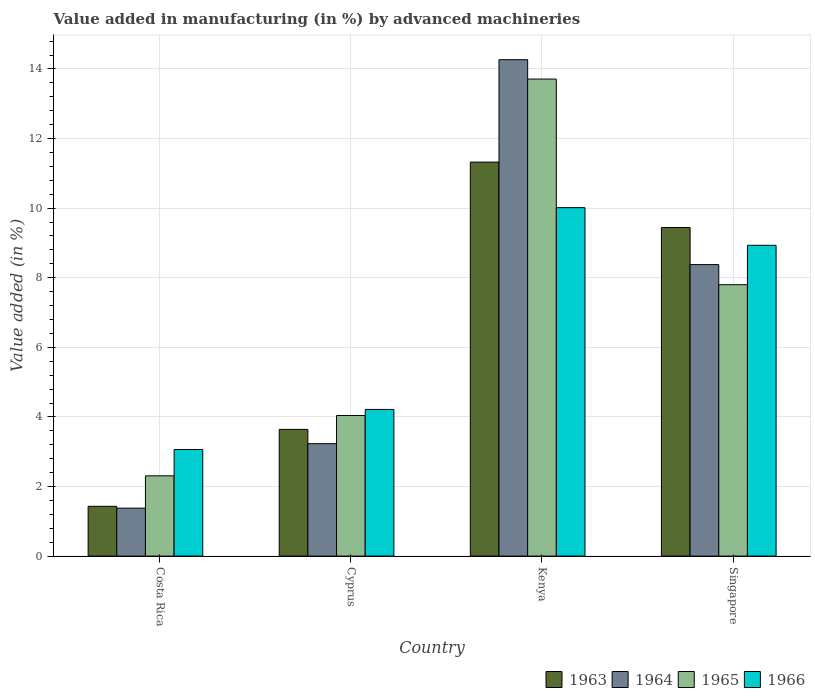How many different coloured bars are there?
Your answer should be compact. 4. How many bars are there on the 4th tick from the right?
Offer a very short reply. 4. What is the label of the 4th group of bars from the left?
Your answer should be very brief. Singapore. What is the percentage of value added in manufacturing by advanced machineries in 1964 in Singapore?
Give a very brief answer. 8.38. Across all countries, what is the maximum percentage of value added in manufacturing by advanced machineries in 1964?
Your response must be concise. 14.27. Across all countries, what is the minimum percentage of value added in manufacturing by advanced machineries in 1966?
Your answer should be compact. 3.06. In which country was the percentage of value added in manufacturing by advanced machineries in 1963 maximum?
Provide a succinct answer. Kenya. What is the total percentage of value added in manufacturing by advanced machineries in 1965 in the graph?
Keep it short and to the point. 27.86. What is the difference between the percentage of value added in manufacturing by advanced machineries in 1966 in Costa Rica and that in Kenya?
Your answer should be very brief. -6.95. What is the difference between the percentage of value added in manufacturing by advanced machineries in 1963 in Cyprus and the percentage of value added in manufacturing by advanced machineries in 1965 in Kenya?
Your response must be concise. -10.07. What is the average percentage of value added in manufacturing by advanced machineries in 1965 per country?
Provide a succinct answer. 6.96. What is the difference between the percentage of value added in manufacturing by advanced machineries of/in 1966 and percentage of value added in manufacturing by advanced machineries of/in 1963 in Kenya?
Your response must be concise. -1.31. What is the ratio of the percentage of value added in manufacturing by advanced machineries in 1965 in Costa Rica to that in Cyprus?
Offer a terse response. 0.57. What is the difference between the highest and the second highest percentage of value added in manufacturing by advanced machineries in 1965?
Offer a very short reply. -9.67. What is the difference between the highest and the lowest percentage of value added in manufacturing by advanced machineries in 1966?
Ensure brevity in your answer.  6.95. In how many countries, is the percentage of value added in manufacturing by advanced machineries in 1966 greater than the average percentage of value added in manufacturing by advanced machineries in 1966 taken over all countries?
Your answer should be very brief. 2. Is the sum of the percentage of value added in manufacturing by advanced machineries in 1963 in Kenya and Singapore greater than the maximum percentage of value added in manufacturing by advanced machineries in 1965 across all countries?
Your answer should be very brief. Yes. Is it the case that in every country, the sum of the percentage of value added in manufacturing by advanced machineries in 1964 and percentage of value added in manufacturing by advanced machineries in 1963 is greater than the sum of percentage of value added in manufacturing by advanced machineries in 1966 and percentage of value added in manufacturing by advanced machineries in 1965?
Provide a short and direct response. No. What does the 3rd bar from the left in Costa Rica represents?
Make the answer very short. 1965. What does the 4th bar from the right in Kenya represents?
Keep it short and to the point. 1963. How many bars are there?
Your answer should be very brief. 16. What is the difference between two consecutive major ticks on the Y-axis?
Ensure brevity in your answer.  2. Are the values on the major ticks of Y-axis written in scientific E-notation?
Your answer should be compact. No. How many legend labels are there?
Offer a terse response. 4. How are the legend labels stacked?
Keep it short and to the point. Horizontal. What is the title of the graph?
Make the answer very short. Value added in manufacturing (in %) by advanced machineries. Does "1978" appear as one of the legend labels in the graph?
Offer a very short reply. No. What is the label or title of the X-axis?
Provide a short and direct response. Country. What is the label or title of the Y-axis?
Your answer should be very brief. Value added (in %). What is the Value added (in %) in 1963 in Costa Rica?
Your answer should be compact. 1.43. What is the Value added (in %) in 1964 in Costa Rica?
Your answer should be compact. 1.38. What is the Value added (in %) in 1965 in Costa Rica?
Give a very brief answer. 2.31. What is the Value added (in %) of 1966 in Costa Rica?
Keep it short and to the point. 3.06. What is the Value added (in %) in 1963 in Cyprus?
Your answer should be very brief. 3.64. What is the Value added (in %) in 1964 in Cyprus?
Make the answer very short. 3.23. What is the Value added (in %) in 1965 in Cyprus?
Keep it short and to the point. 4.04. What is the Value added (in %) of 1966 in Cyprus?
Your response must be concise. 4.22. What is the Value added (in %) in 1963 in Kenya?
Keep it short and to the point. 11.32. What is the Value added (in %) of 1964 in Kenya?
Your answer should be compact. 14.27. What is the Value added (in %) in 1965 in Kenya?
Your answer should be very brief. 13.71. What is the Value added (in %) of 1966 in Kenya?
Make the answer very short. 10.01. What is the Value added (in %) in 1963 in Singapore?
Offer a very short reply. 9.44. What is the Value added (in %) in 1964 in Singapore?
Ensure brevity in your answer.  8.38. What is the Value added (in %) in 1965 in Singapore?
Provide a succinct answer. 7.8. What is the Value added (in %) in 1966 in Singapore?
Ensure brevity in your answer.  8.93. Across all countries, what is the maximum Value added (in %) of 1963?
Ensure brevity in your answer.  11.32. Across all countries, what is the maximum Value added (in %) in 1964?
Your answer should be very brief. 14.27. Across all countries, what is the maximum Value added (in %) of 1965?
Keep it short and to the point. 13.71. Across all countries, what is the maximum Value added (in %) in 1966?
Ensure brevity in your answer.  10.01. Across all countries, what is the minimum Value added (in %) in 1963?
Your answer should be compact. 1.43. Across all countries, what is the minimum Value added (in %) of 1964?
Provide a short and direct response. 1.38. Across all countries, what is the minimum Value added (in %) of 1965?
Keep it short and to the point. 2.31. Across all countries, what is the minimum Value added (in %) of 1966?
Ensure brevity in your answer.  3.06. What is the total Value added (in %) in 1963 in the graph?
Your answer should be very brief. 25.84. What is the total Value added (in %) of 1964 in the graph?
Provide a short and direct response. 27.25. What is the total Value added (in %) in 1965 in the graph?
Your answer should be very brief. 27.86. What is the total Value added (in %) of 1966 in the graph?
Provide a succinct answer. 26.23. What is the difference between the Value added (in %) in 1963 in Costa Rica and that in Cyprus?
Keep it short and to the point. -2.21. What is the difference between the Value added (in %) in 1964 in Costa Rica and that in Cyprus?
Provide a succinct answer. -1.85. What is the difference between the Value added (in %) of 1965 in Costa Rica and that in Cyprus?
Your answer should be compact. -1.73. What is the difference between the Value added (in %) of 1966 in Costa Rica and that in Cyprus?
Provide a short and direct response. -1.15. What is the difference between the Value added (in %) in 1963 in Costa Rica and that in Kenya?
Give a very brief answer. -9.89. What is the difference between the Value added (in %) of 1964 in Costa Rica and that in Kenya?
Ensure brevity in your answer.  -12.89. What is the difference between the Value added (in %) of 1965 in Costa Rica and that in Kenya?
Keep it short and to the point. -11.4. What is the difference between the Value added (in %) of 1966 in Costa Rica and that in Kenya?
Provide a succinct answer. -6.95. What is the difference between the Value added (in %) in 1963 in Costa Rica and that in Singapore?
Your answer should be very brief. -8.01. What is the difference between the Value added (in %) in 1964 in Costa Rica and that in Singapore?
Your response must be concise. -7. What is the difference between the Value added (in %) of 1965 in Costa Rica and that in Singapore?
Your answer should be compact. -5.49. What is the difference between the Value added (in %) of 1966 in Costa Rica and that in Singapore?
Your response must be concise. -5.87. What is the difference between the Value added (in %) of 1963 in Cyprus and that in Kenya?
Provide a succinct answer. -7.68. What is the difference between the Value added (in %) in 1964 in Cyprus and that in Kenya?
Keep it short and to the point. -11.04. What is the difference between the Value added (in %) of 1965 in Cyprus and that in Kenya?
Your answer should be very brief. -9.67. What is the difference between the Value added (in %) of 1966 in Cyprus and that in Kenya?
Keep it short and to the point. -5.8. What is the difference between the Value added (in %) in 1963 in Cyprus and that in Singapore?
Your response must be concise. -5.8. What is the difference between the Value added (in %) in 1964 in Cyprus and that in Singapore?
Keep it short and to the point. -5.15. What is the difference between the Value added (in %) of 1965 in Cyprus and that in Singapore?
Your answer should be compact. -3.76. What is the difference between the Value added (in %) in 1966 in Cyprus and that in Singapore?
Make the answer very short. -4.72. What is the difference between the Value added (in %) of 1963 in Kenya and that in Singapore?
Your answer should be compact. 1.88. What is the difference between the Value added (in %) in 1964 in Kenya and that in Singapore?
Keep it short and to the point. 5.89. What is the difference between the Value added (in %) of 1965 in Kenya and that in Singapore?
Your answer should be compact. 5.91. What is the difference between the Value added (in %) in 1966 in Kenya and that in Singapore?
Your answer should be very brief. 1.08. What is the difference between the Value added (in %) in 1963 in Costa Rica and the Value added (in %) in 1964 in Cyprus?
Keep it short and to the point. -1.8. What is the difference between the Value added (in %) of 1963 in Costa Rica and the Value added (in %) of 1965 in Cyprus?
Keep it short and to the point. -2.61. What is the difference between the Value added (in %) in 1963 in Costa Rica and the Value added (in %) in 1966 in Cyprus?
Provide a succinct answer. -2.78. What is the difference between the Value added (in %) of 1964 in Costa Rica and the Value added (in %) of 1965 in Cyprus?
Provide a succinct answer. -2.66. What is the difference between the Value added (in %) in 1964 in Costa Rica and the Value added (in %) in 1966 in Cyprus?
Keep it short and to the point. -2.84. What is the difference between the Value added (in %) of 1965 in Costa Rica and the Value added (in %) of 1966 in Cyprus?
Your response must be concise. -1.91. What is the difference between the Value added (in %) of 1963 in Costa Rica and the Value added (in %) of 1964 in Kenya?
Offer a terse response. -12.84. What is the difference between the Value added (in %) in 1963 in Costa Rica and the Value added (in %) in 1965 in Kenya?
Make the answer very short. -12.28. What is the difference between the Value added (in %) in 1963 in Costa Rica and the Value added (in %) in 1966 in Kenya?
Offer a terse response. -8.58. What is the difference between the Value added (in %) of 1964 in Costa Rica and the Value added (in %) of 1965 in Kenya?
Your answer should be compact. -12.33. What is the difference between the Value added (in %) of 1964 in Costa Rica and the Value added (in %) of 1966 in Kenya?
Give a very brief answer. -8.64. What is the difference between the Value added (in %) of 1965 in Costa Rica and the Value added (in %) of 1966 in Kenya?
Provide a short and direct response. -7.71. What is the difference between the Value added (in %) in 1963 in Costa Rica and the Value added (in %) in 1964 in Singapore?
Ensure brevity in your answer.  -6.95. What is the difference between the Value added (in %) in 1963 in Costa Rica and the Value added (in %) in 1965 in Singapore?
Give a very brief answer. -6.37. What is the difference between the Value added (in %) in 1963 in Costa Rica and the Value added (in %) in 1966 in Singapore?
Ensure brevity in your answer.  -7.5. What is the difference between the Value added (in %) of 1964 in Costa Rica and the Value added (in %) of 1965 in Singapore?
Offer a terse response. -6.42. What is the difference between the Value added (in %) of 1964 in Costa Rica and the Value added (in %) of 1966 in Singapore?
Your answer should be compact. -7.55. What is the difference between the Value added (in %) of 1965 in Costa Rica and the Value added (in %) of 1966 in Singapore?
Provide a succinct answer. -6.63. What is the difference between the Value added (in %) in 1963 in Cyprus and the Value added (in %) in 1964 in Kenya?
Make the answer very short. -10.63. What is the difference between the Value added (in %) of 1963 in Cyprus and the Value added (in %) of 1965 in Kenya?
Give a very brief answer. -10.07. What is the difference between the Value added (in %) in 1963 in Cyprus and the Value added (in %) in 1966 in Kenya?
Offer a terse response. -6.37. What is the difference between the Value added (in %) of 1964 in Cyprus and the Value added (in %) of 1965 in Kenya?
Give a very brief answer. -10.48. What is the difference between the Value added (in %) in 1964 in Cyprus and the Value added (in %) in 1966 in Kenya?
Offer a terse response. -6.78. What is the difference between the Value added (in %) in 1965 in Cyprus and the Value added (in %) in 1966 in Kenya?
Your answer should be compact. -5.97. What is the difference between the Value added (in %) of 1963 in Cyprus and the Value added (in %) of 1964 in Singapore?
Ensure brevity in your answer.  -4.74. What is the difference between the Value added (in %) of 1963 in Cyprus and the Value added (in %) of 1965 in Singapore?
Offer a terse response. -4.16. What is the difference between the Value added (in %) in 1963 in Cyprus and the Value added (in %) in 1966 in Singapore?
Keep it short and to the point. -5.29. What is the difference between the Value added (in %) of 1964 in Cyprus and the Value added (in %) of 1965 in Singapore?
Your answer should be very brief. -4.57. What is the difference between the Value added (in %) of 1964 in Cyprus and the Value added (in %) of 1966 in Singapore?
Provide a short and direct response. -5.7. What is the difference between the Value added (in %) of 1965 in Cyprus and the Value added (in %) of 1966 in Singapore?
Your answer should be compact. -4.89. What is the difference between the Value added (in %) in 1963 in Kenya and the Value added (in %) in 1964 in Singapore?
Your response must be concise. 2.95. What is the difference between the Value added (in %) in 1963 in Kenya and the Value added (in %) in 1965 in Singapore?
Your response must be concise. 3.52. What is the difference between the Value added (in %) in 1963 in Kenya and the Value added (in %) in 1966 in Singapore?
Your answer should be compact. 2.39. What is the difference between the Value added (in %) of 1964 in Kenya and the Value added (in %) of 1965 in Singapore?
Give a very brief answer. 6.47. What is the difference between the Value added (in %) in 1964 in Kenya and the Value added (in %) in 1966 in Singapore?
Your response must be concise. 5.33. What is the difference between the Value added (in %) in 1965 in Kenya and the Value added (in %) in 1966 in Singapore?
Your response must be concise. 4.78. What is the average Value added (in %) of 1963 per country?
Provide a short and direct response. 6.46. What is the average Value added (in %) of 1964 per country?
Provide a succinct answer. 6.81. What is the average Value added (in %) of 1965 per country?
Keep it short and to the point. 6.96. What is the average Value added (in %) in 1966 per country?
Make the answer very short. 6.56. What is the difference between the Value added (in %) in 1963 and Value added (in %) in 1964 in Costa Rica?
Your response must be concise. 0.05. What is the difference between the Value added (in %) of 1963 and Value added (in %) of 1965 in Costa Rica?
Provide a short and direct response. -0.88. What is the difference between the Value added (in %) in 1963 and Value added (in %) in 1966 in Costa Rica?
Ensure brevity in your answer.  -1.63. What is the difference between the Value added (in %) of 1964 and Value added (in %) of 1965 in Costa Rica?
Make the answer very short. -0.93. What is the difference between the Value added (in %) of 1964 and Value added (in %) of 1966 in Costa Rica?
Your answer should be compact. -1.69. What is the difference between the Value added (in %) in 1965 and Value added (in %) in 1966 in Costa Rica?
Keep it short and to the point. -0.76. What is the difference between the Value added (in %) of 1963 and Value added (in %) of 1964 in Cyprus?
Make the answer very short. 0.41. What is the difference between the Value added (in %) in 1963 and Value added (in %) in 1965 in Cyprus?
Your response must be concise. -0.4. What is the difference between the Value added (in %) in 1963 and Value added (in %) in 1966 in Cyprus?
Provide a succinct answer. -0.57. What is the difference between the Value added (in %) in 1964 and Value added (in %) in 1965 in Cyprus?
Offer a terse response. -0.81. What is the difference between the Value added (in %) in 1964 and Value added (in %) in 1966 in Cyprus?
Provide a short and direct response. -0.98. What is the difference between the Value added (in %) of 1965 and Value added (in %) of 1966 in Cyprus?
Your response must be concise. -0.17. What is the difference between the Value added (in %) in 1963 and Value added (in %) in 1964 in Kenya?
Your answer should be compact. -2.94. What is the difference between the Value added (in %) of 1963 and Value added (in %) of 1965 in Kenya?
Provide a short and direct response. -2.39. What is the difference between the Value added (in %) in 1963 and Value added (in %) in 1966 in Kenya?
Provide a short and direct response. 1.31. What is the difference between the Value added (in %) in 1964 and Value added (in %) in 1965 in Kenya?
Offer a terse response. 0.56. What is the difference between the Value added (in %) in 1964 and Value added (in %) in 1966 in Kenya?
Provide a short and direct response. 4.25. What is the difference between the Value added (in %) of 1965 and Value added (in %) of 1966 in Kenya?
Your answer should be very brief. 3.7. What is the difference between the Value added (in %) of 1963 and Value added (in %) of 1964 in Singapore?
Ensure brevity in your answer.  1.07. What is the difference between the Value added (in %) of 1963 and Value added (in %) of 1965 in Singapore?
Your answer should be very brief. 1.64. What is the difference between the Value added (in %) in 1963 and Value added (in %) in 1966 in Singapore?
Ensure brevity in your answer.  0.51. What is the difference between the Value added (in %) of 1964 and Value added (in %) of 1965 in Singapore?
Make the answer very short. 0.58. What is the difference between the Value added (in %) of 1964 and Value added (in %) of 1966 in Singapore?
Offer a very short reply. -0.55. What is the difference between the Value added (in %) of 1965 and Value added (in %) of 1966 in Singapore?
Your answer should be very brief. -1.13. What is the ratio of the Value added (in %) in 1963 in Costa Rica to that in Cyprus?
Make the answer very short. 0.39. What is the ratio of the Value added (in %) in 1964 in Costa Rica to that in Cyprus?
Offer a very short reply. 0.43. What is the ratio of the Value added (in %) of 1965 in Costa Rica to that in Cyprus?
Your response must be concise. 0.57. What is the ratio of the Value added (in %) in 1966 in Costa Rica to that in Cyprus?
Keep it short and to the point. 0.73. What is the ratio of the Value added (in %) of 1963 in Costa Rica to that in Kenya?
Ensure brevity in your answer.  0.13. What is the ratio of the Value added (in %) in 1964 in Costa Rica to that in Kenya?
Give a very brief answer. 0.1. What is the ratio of the Value added (in %) of 1965 in Costa Rica to that in Kenya?
Keep it short and to the point. 0.17. What is the ratio of the Value added (in %) of 1966 in Costa Rica to that in Kenya?
Keep it short and to the point. 0.31. What is the ratio of the Value added (in %) of 1963 in Costa Rica to that in Singapore?
Keep it short and to the point. 0.15. What is the ratio of the Value added (in %) in 1964 in Costa Rica to that in Singapore?
Your response must be concise. 0.16. What is the ratio of the Value added (in %) of 1965 in Costa Rica to that in Singapore?
Your answer should be compact. 0.3. What is the ratio of the Value added (in %) in 1966 in Costa Rica to that in Singapore?
Make the answer very short. 0.34. What is the ratio of the Value added (in %) of 1963 in Cyprus to that in Kenya?
Offer a terse response. 0.32. What is the ratio of the Value added (in %) in 1964 in Cyprus to that in Kenya?
Provide a succinct answer. 0.23. What is the ratio of the Value added (in %) in 1965 in Cyprus to that in Kenya?
Give a very brief answer. 0.29. What is the ratio of the Value added (in %) of 1966 in Cyprus to that in Kenya?
Provide a short and direct response. 0.42. What is the ratio of the Value added (in %) of 1963 in Cyprus to that in Singapore?
Provide a succinct answer. 0.39. What is the ratio of the Value added (in %) in 1964 in Cyprus to that in Singapore?
Offer a terse response. 0.39. What is the ratio of the Value added (in %) in 1965 in Cyprus to that in Singapore?
Provide a succinct answer. 0.52. What is the ratio of the Value added (in %) of 1966 in Cyprus to that in Singapore?
Offer a terse response. 0.47. What is the ratio of the Value added (in %) of 1963 in Kenya to that in Singapore?
Offer a very short reply. 1.2. What is the ratio of the Value added (in %) in 1964 in Kenya to that in Singapore?
Ensure brevity in your answer.  1.7. What is the ratio of the Value added (in %) in 1965 in Kenya to that in Singapore?
Make the answer very short. 1.76. What is the ratio of the Value added (in %) in 1966 in Kenya to that in Singapore?
Give a very brief answer. 1.12. What is the difference between the highest and the second highest Value added (in %) of 1963?
Offer a very short reply. 1.88. What is the difference between the highest and the second highest Value added (in %) of 1964?
Ensure brevity in your answer.  5.89. What is the difference between the highest and the second highest Value added (in %) of 1965?
Make the answer very short. 5.91. What is the difference between the highest and the second highest Value added (in %) of 1966?
Give a very brief answer. 1.08. What is the difference between the highest and the lowest Value added (in %) of 1963?
Provide a succinct answer. 9.89. What is the difference between the highest and the lowest Value added (in %) in 1964?
Your response must be concise. 12.89. What is the difference between the highest and the lowest Value added (in %) in 1965?
Provide a short and direct response. 11.4. What is the difference between the highest and the lowest Value added (in %) of 1966?
Give a very brief answer. 6.95. 